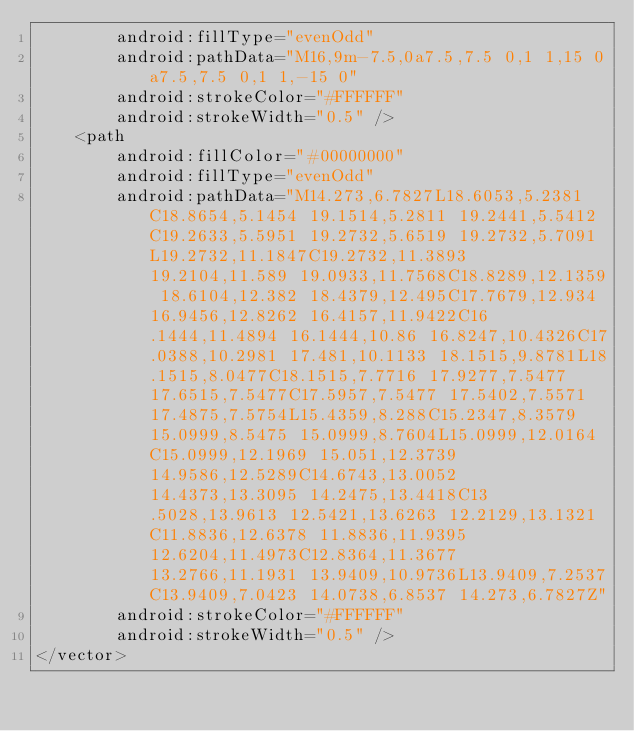Convert code to text. <code><loc_0><loc_0><loc_500><loc_500><_XML_>        android:fillType="evenOdd"
        android:pathData="M16,9m-7.5,0a7.5,7.5 0,1 1,15 0a7.5,7.5 0,1 1,-15 0"
        android:strokeColor="#FFFFFF"
        android:strokeWidth="0.5" />
    <path
        android:fillColor="#00000000"
        android:fillType="evenOdd"
        android:pathData="M14.273,6.7827L18.6053,5.2381C18.8654,5.1454 19.1514,5.2811 19.2441,5.5412C19.2633,5.5951 19.2732,5.6519 19.2732,5.7091L19.2732,11.1847C19.2732,11.3893 19.2104,11.589 19.0933,11.7568C18.8289,12.1359 18.6104,12.382 18.4379,12.495C17.7679,12.934 16.9456,12.8262 16.4157,11.9422C16.1444,11.4894 16.1444,10.86 16.8247,10.4326C17.0388,10.2981 17.481,10.1133 18.1515,9.8781L18.1515,8.0477C18.1515,7.7716 17.9277,7.5477 17.6515,7.5477C17.5957,7.5477 17.5402,7.5571 17.4875,7.5754L15.4359,8.288C15.2347,8.3579 15.0999,8.5475 15.0999,8.7604L15.0999,12.0164C15.0999,12.1969 15.051,12.3739 14.9586,12.5289C14.6743,13.0052 14.4373,13.3095 14.2475,13.4418C13.5028,13.9613 12.5421,13.6263 12.2129,13.1321C11.8836,12.6378 11.8836,11.9395 12.6204,11.4973C12.8364,11.3677 13.2766,11.1931 13.9409,10.9736L13.9409,7.2537C13.9409,7.0423 14.0738,6.8537 14.273,6.7827Z"
        android:strokeColor="#FFFFFF"
        android:strokeWidth="0.5" />
</vector></code> 